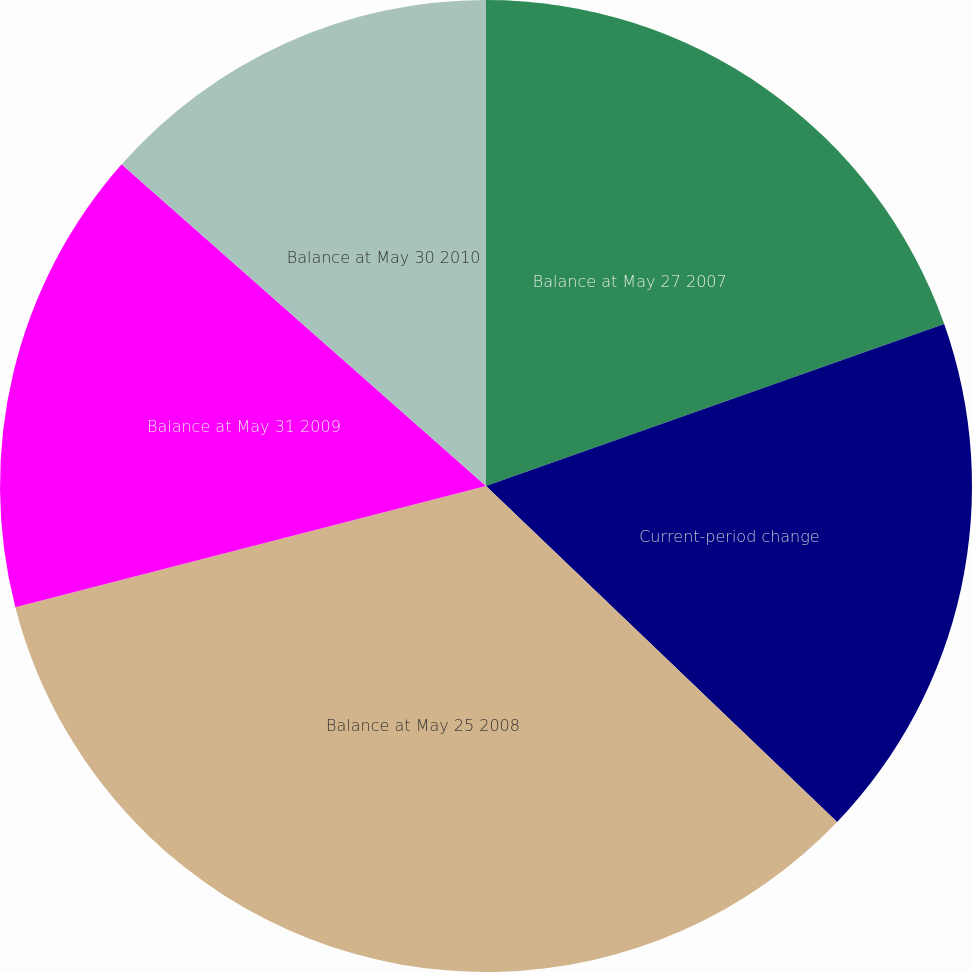Convert chart to OTSL. <chart><loc_0><loc_0><loc_500><loc_500><pie_chart><fcel>Balance at May 27 2007<fcel>Current-period change<fcel>Balance at May 25 2008<fcel>Balance at May 31 2009<fcel>Balance at May 30 2010<nl><fcel>19.59%<fcel>17.56%<fcel>33.84%<fcel>15.52%<fcel>13.49%<nl></chart> 